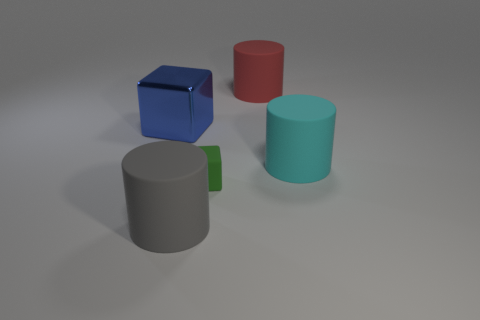Subtract all large cyan cylinders. How many cylinders are left? 2 Add 2 large shiny cubes. How many objects exist? 7 Subtract all red cylinders. How many cylinders are left? 2 Subtract 1 cylinders. How many cylinders are left? 2 Subtract all cylinders. How many objects are left? 2 Subtract all small brown cubes. Subtract all large matte things. How many objects are left? 2 Add 3 small blocks. How many small blocks are left? 4 Add 1 small yellow spheres. How many small yellow spheres exist? 1 Subtract 0 purple cylinders. How many objects are left? 5 Subtract all green cylinders. Subtract all blue spheres. How many cylinders are left? 3 